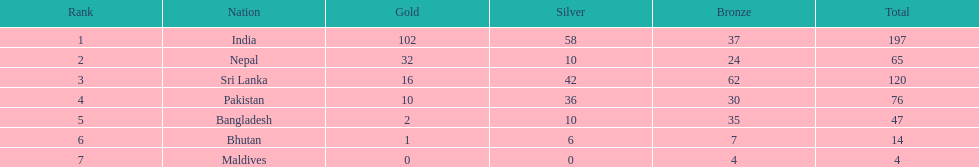Which nations were involved in the 1999 south asian games? India, Nepal, Sri Lanka, Pakistan, Bangladesh, Bhutan, Maldives. Which country holds the second position in the table? Nepal. 